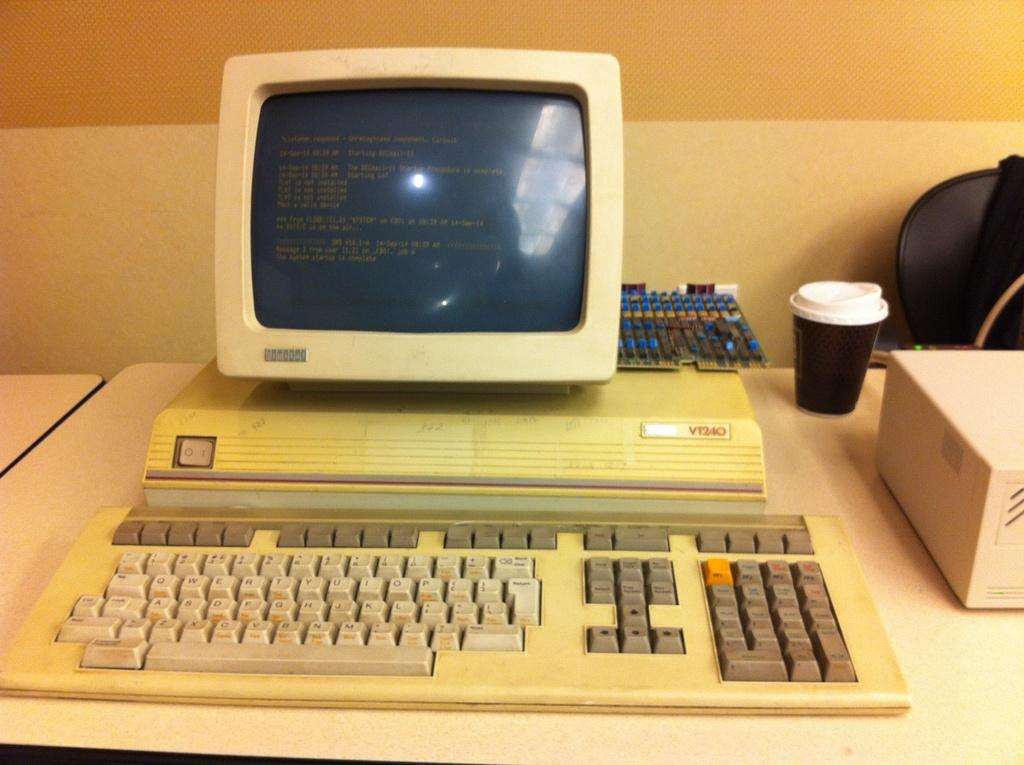<image>
Provide a brief description of the given image. Old computer with the word VT240 on it. 